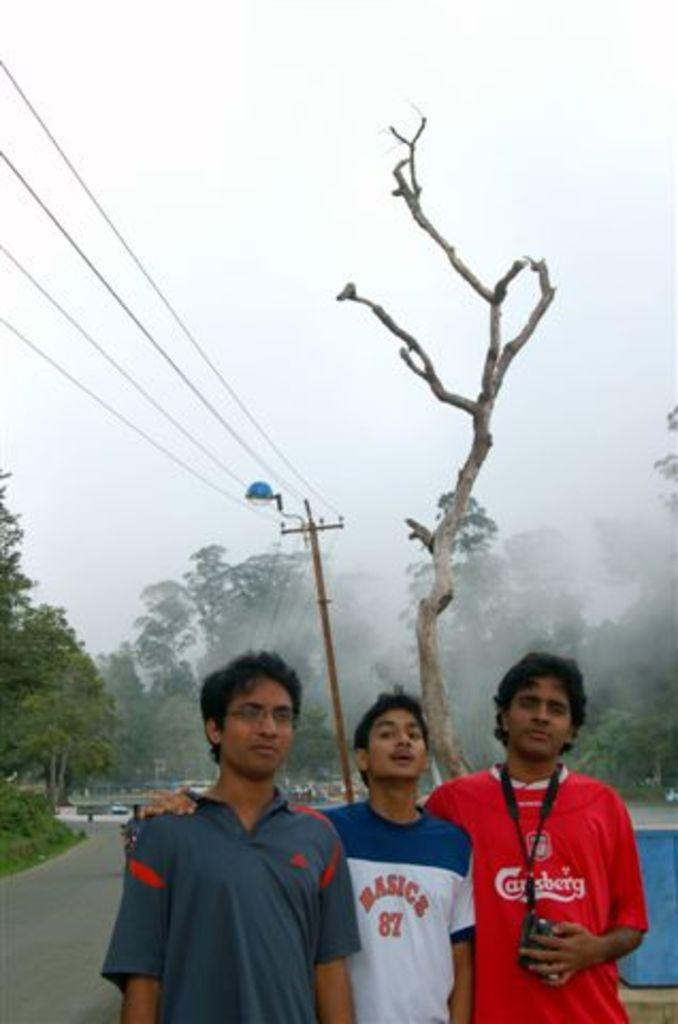Provide a one-sentence caption for the provided image. A young man wearing a Carlsberg Beer t-shirt poses with two of his friends. 